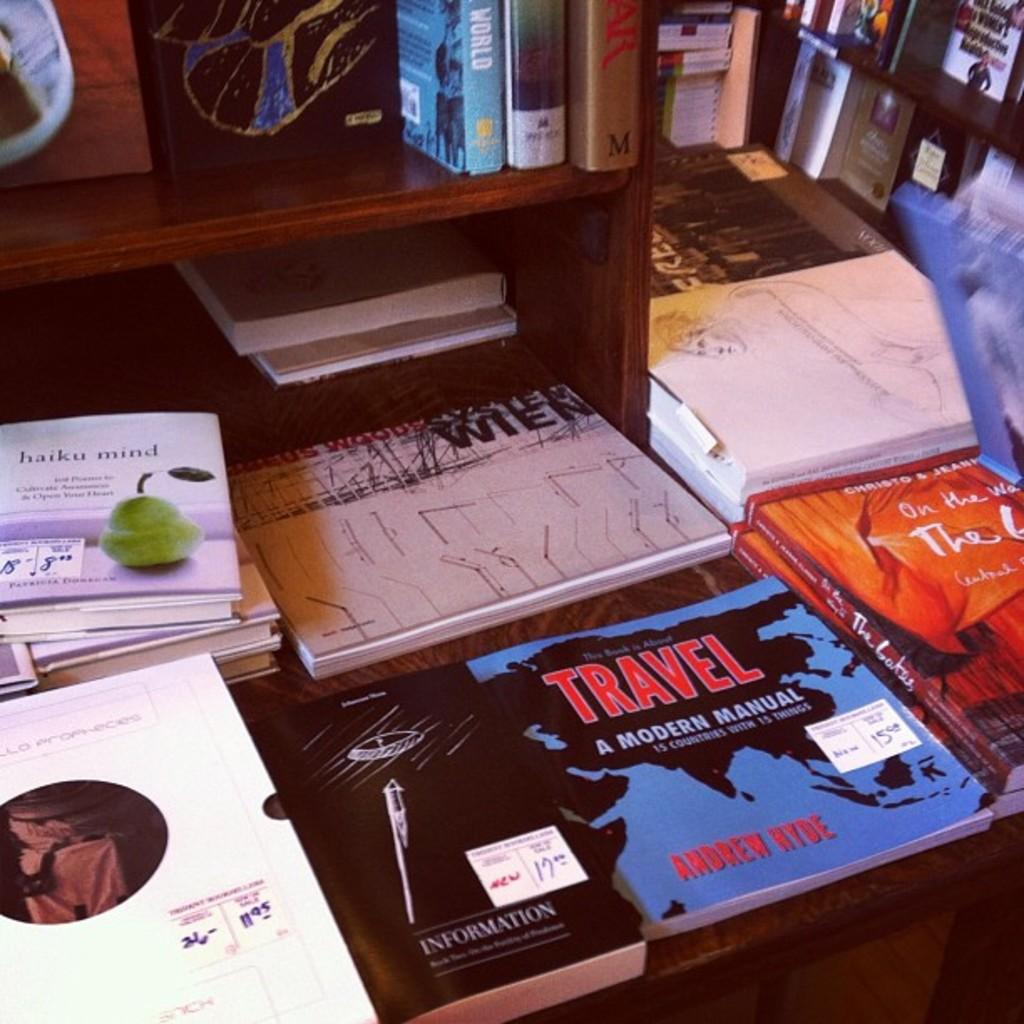<image>
Offer a succinct explanation of the picture presented. A variety of different books are arranged on a table with one of them being Travel a modern manual being one of them. 